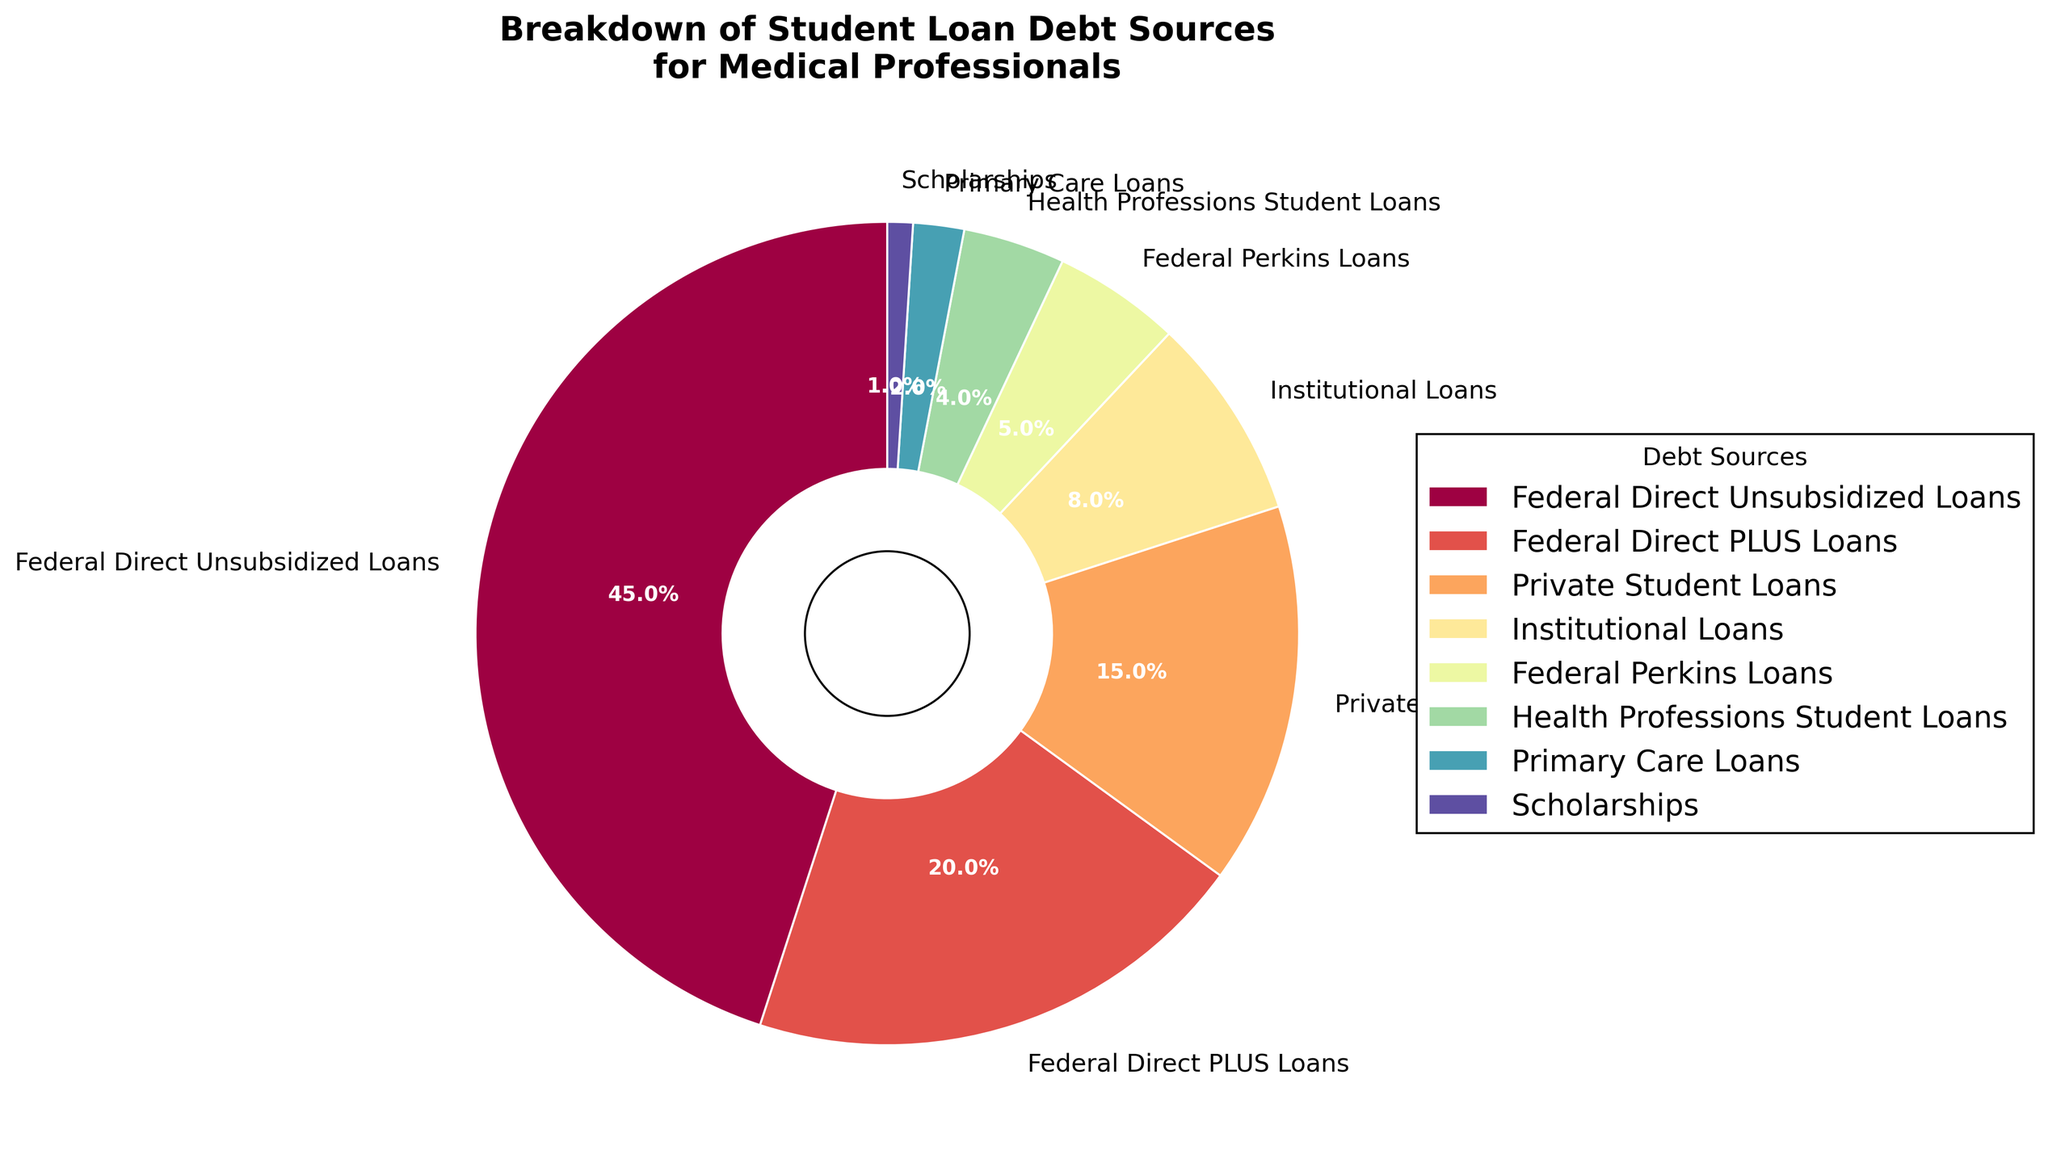What are the sources with the highest and lowest percentages? The highest percentage is given by the 'Federal Direct Unsubsidized Loans' slice, which is 45%. The lowest percentage is the 'Scholarships' slice, at 1%.
Answer: Federal Direct Unsubsidized Loans (45%) and Scholarships (1%) Which loan source accounts for 20% of the student loan debt? Identify the slice labeled with 20% on the pie chart; it corresponds to 'Federal Direct PLUS Loans'.
Answer: Federal Direct PLUS Loans How much more percentage do Federal Direct Unsubsidized Loans account for compared to Private Student Loans? Federal Direct Unsubsidized Loans account for 45%, and Private Student Loans account for 15%. The difference is 45% - 15% = 30%.
Answer: 30% What is the combined percentage of Institutional Loans and Health Professions Student Loans? Institutional Loans account for 8%, and Health Professions Student Loans account for 4%. Summing these gives 8% + 4% = 12%.
Answer: 12% Which debt source is represented by the smallest wedge in the pie chart? By looking at the smallest wedge in the chart, it corresponds to 'Scholarships', which is 1%.
Answer: Scholarships Compare the proportions of Federal Perkins Loans and Primary Care Loans. Which one has a higher percentage, and by how much? Federal Perkins Loans have 5%, while Primary Care Loans have 2%. The difference is 5% - 2% = 3%. Federal Perkins Loans have a higher percentage by 3%.
Answer: Federal Perkins Loans by 3% What is the total percentage represented by Federal Direct Unsubsidized Loans and Federal Direct PLUS Loans combined? Federal Direct Unsubsidized Loans have 45%, and Federal Direct PLUS Loans have 20%. The total is 45% + 20% = 65%.
Answer: 65% Identify the sources that individually account for less than 10% of the student loan debt. The sources with percentages less than 10% are Private Student Loans (15%), Institutional Loans (8%), Federal Perkins Loans (5%), Health Professions Student Loans (4%), Primary Care Loans (2%), and Scholarships (1%).
Answer: Institutional Loans, Federal Perkins Loans, Health Professions Student Loans, Primary Care Loans, Scholarships What is the percentage difference between the Federal Direct PLUS Loans and the sum of Institutional Loans and Federal Perkins Loans? Federal Direct PLUS Loans have 20%. The sum of Institutional Loans (8%) and Federal Perkins Loans (5%) is 8% + 5% = 13%. The difference is 20% - 13% = 7%.
Answer: 7% 